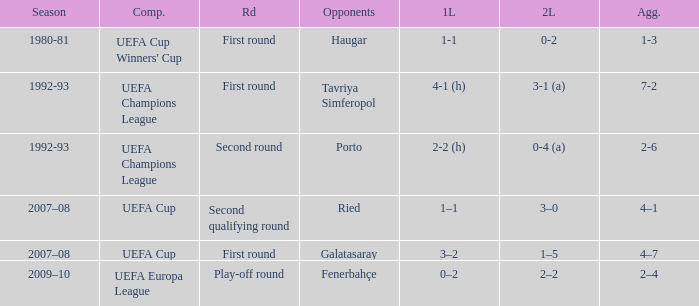 what's the competition where 1st leg is 4-1 (h) UEFA Champions League. 